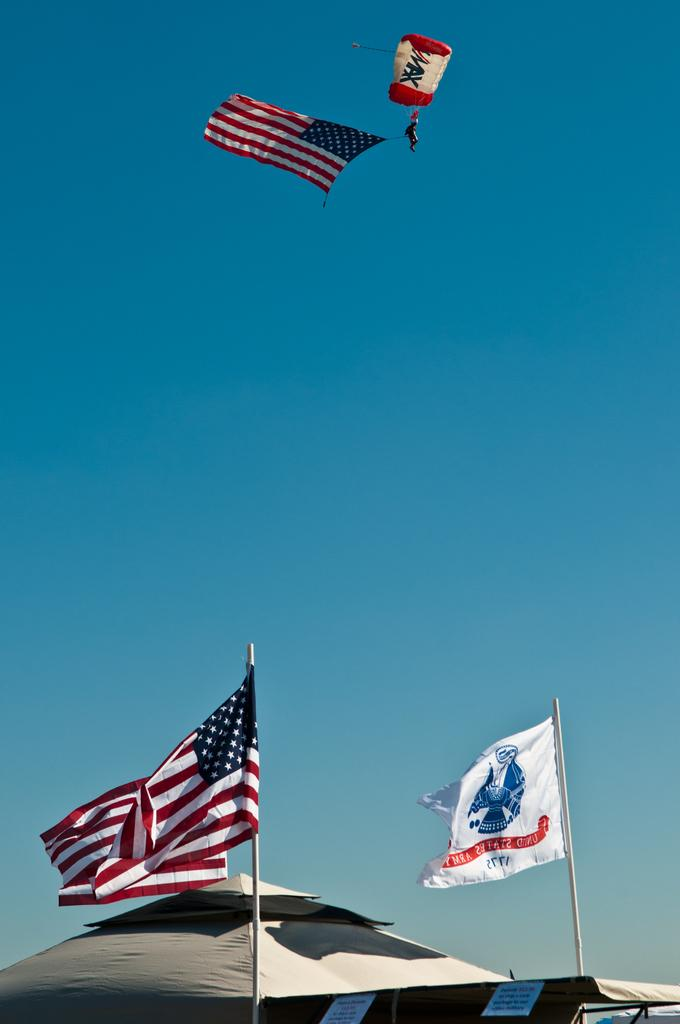What objects are located at the front of the image? There are flags in the front of the image. What structures can be seen in the image? There are tents in the image. What is visible in the sky in the image? There is a parachute visible in the sky. Are there any other flags in the image besides the ones at the front? Yes, there is a flag in the sky. Where is the shelf located in the image? There is no shelf present in the image. What type of fuel is being used by the parachute in the image? The image does not provide information about the type of fuel being used, as parachutes do not require fuel to function. 